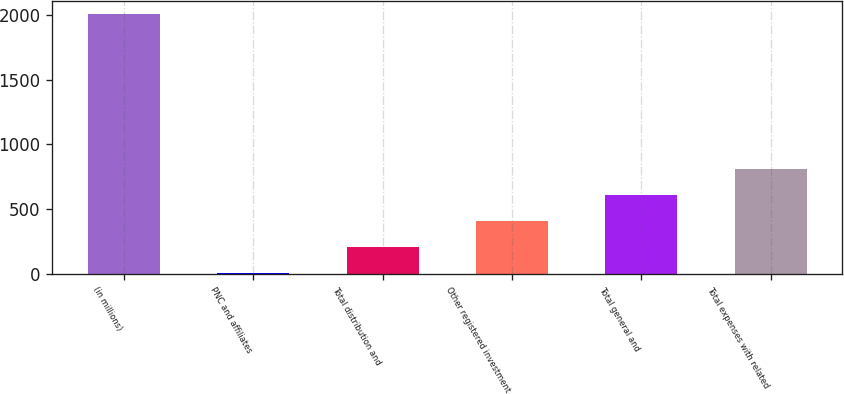Convert chart to OTSL. <chart><loc_0><loc_0><loc_500><loc_500><bar_chart><fcel>(in millions)<fcel>PNC and affiliates<fcel>Total distribution and<fcel>Other registered investment<fcel>Total general and<fcel>Total expenses with related<nl><fcel>2013<fcel>2<fcel>203.1<fcel>404.2<fcel>605.3<fcel>806.4<nl></chart> 